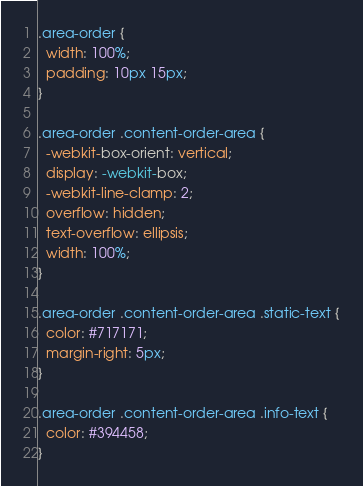Convert code to text. <code><loc_0><loc_0><loc_500><loc_500><_CSS_>.area-order {
  width: 100%;
  padding: 10px 15px;
}

.area-order .content-order-area {
  -webkit-box-orient: vertical;
  display: -webkit-box;
  -webkit-line-clamp: 2;
  overflow: hidden;
  text-overflow: ellipsis;
  width: 100%;
}

.area-order .content-order-area .static-text {
  color: #717171;
  margin-right: 5px;
}

.area-order .content-order-area .info-text {
  color: #394458;
}</code> 